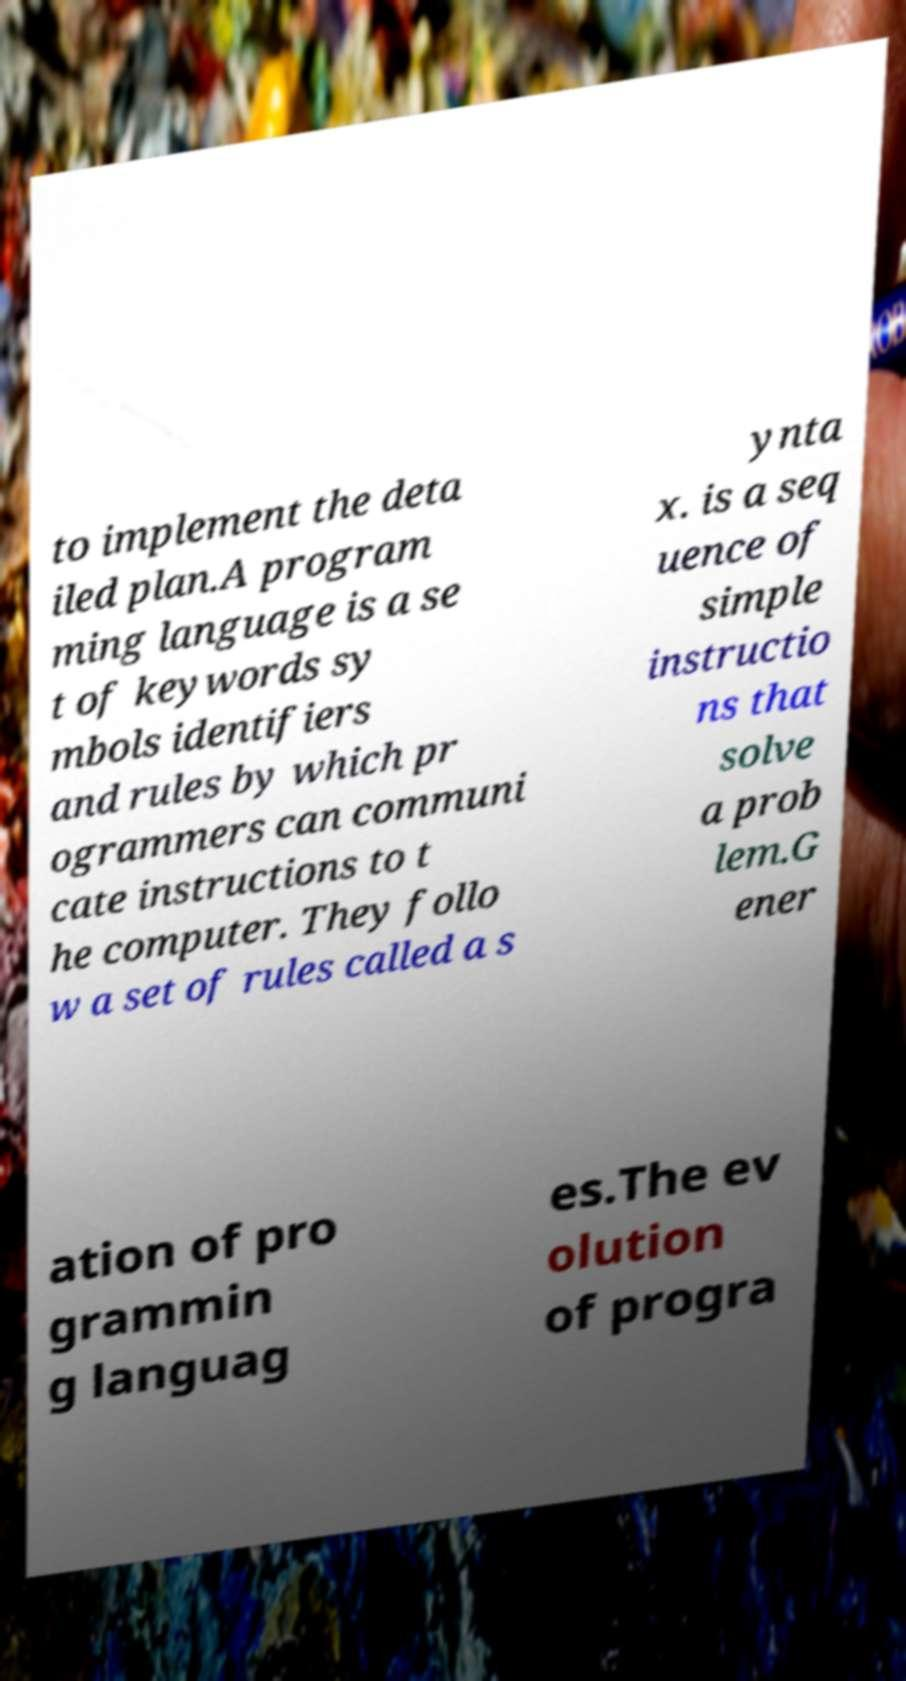Please read and relay the text visible in this image. What does it say? to implement the deta iled plan.A program ming language is a se t of keywords sy mbols identifiers and rules by which pr ogrammers can communi cate instructions to t he computer. They follo w a set of rules called a s ynta x. is a seq uence of simple instructio ns that solve a prob lem.G ener ation of pro grammin g languag es.The ev olution of progra 